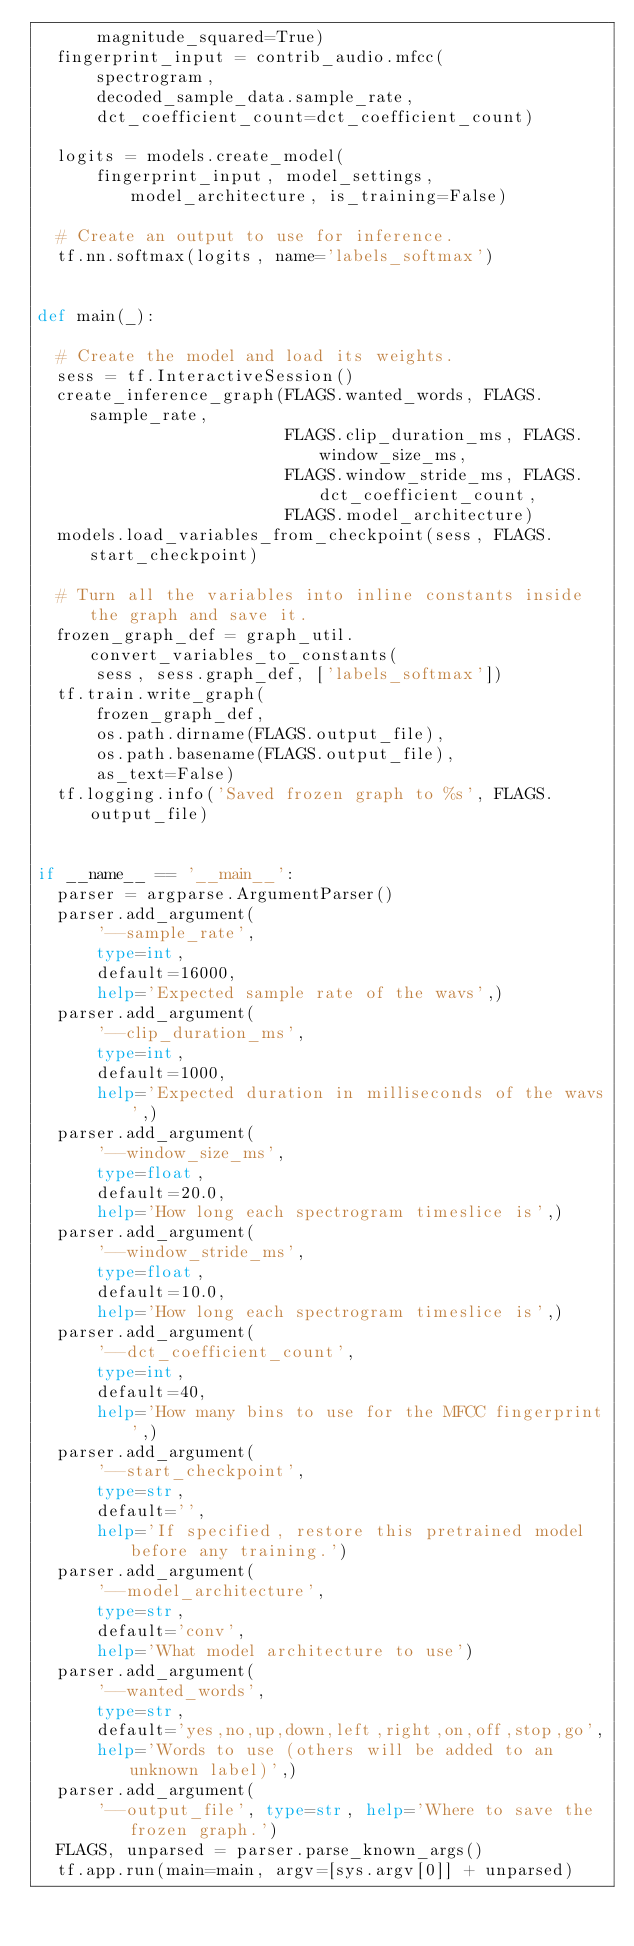Convert code to text. <code><loc_0><loc_0><loc_500><loc_500><_Python_>      magnitude_squared=True)
  fingerprint_input = contrib_audio.mfcc(
      spectrogram,
      decoded_sample_data.sample_rate,
      dct_coefficient_count=dct_coefficient_count)

  logits = models.create_model(
      fingerprint_input, model_settings, model_architecture, is_training=False)

  # Create an output to use for inference.
  tf.nn.softmax(logits, name='labels_softmax')


def main(_):

  # Create the model and load its weights.
  sess = tf.InteractiveSession()
  create_inference_graph(FLAGS.wanted_words, FLAGS.sample_rate,
                         FLAGS.clip_duration_ms, FLAGS.window_size_ms,
                         FLAGS.window_stride_ms, FLAGS.dct_coefficient_count,
                         FLAGS.model_architecture)
  models.load_variables_from_checkpoint(sess, FLAGS.start_checkpoint)

  # Turn all the variables into inline constants inside the graph and save it.
  frozen_graph_def = graph_util.convert_variables_to_constants(
      sess, sess.graph_def, ['labels_softmax'])
  tf.train.write_graph(
      frozen_graph_def,
      os.path.dirname(FLAGS.output_file),
      os.path.basename(FLAGS.output_file),
      as_text=False)
  tf.logging.info('Saved frozen graph to %s', FLAGS.output_file)


if __name__ == '__main__':
  parser = argparse.ArgumentParser()
  parser.add_argument(
      '--sample_rate',
      type=int,
      default=16000,
      help='Expected sample rate of the wavs',)
  parser.add_argument(
      '--clip_duration_ms',
      type=int,
      default=1000,
      help='Expected duration in milliseconds of the wavs',)
  parser.add_argument(
      '--window_size_ms',
      type=float,
      default=20.0,
      help='How long each spectrogram timeslice is',)
  parser.add_argument(
      '--window_stride_ms',
      type=float,
      default=10.0,
      help='How long each spectrogram timeslice is',)
  parser.add_argument(
      '--dct_coefficient_count',
      type=int,
      default=40,
      help='How many bins to use for the MFCC fingerprint',)
  parser.add_argument(
      '--start_checkpoint',
      type=str,
      default='',
      help='If specified, restore this pretrained model before any training.')
  parser.add_argument(
      '--model_architecture',
      type=str,
      default='conv',
      help='What model architecture to use')
  parser.add_argument(
      '--wanted_words',
      type=str,
      default='yes,no,up,down,left,right,on,off,stop,go',
      help='Words to use (others will be added to an unknown label)',)
  parser.add_argument(
      '--output_file', type=str, help='Where to save the frozen graph.')
  FLAGS, unparsed = parser.parse_known_args()
  tf.app.run(main=main, argv=[sys.argv[0]] + unparsed)
</code> 